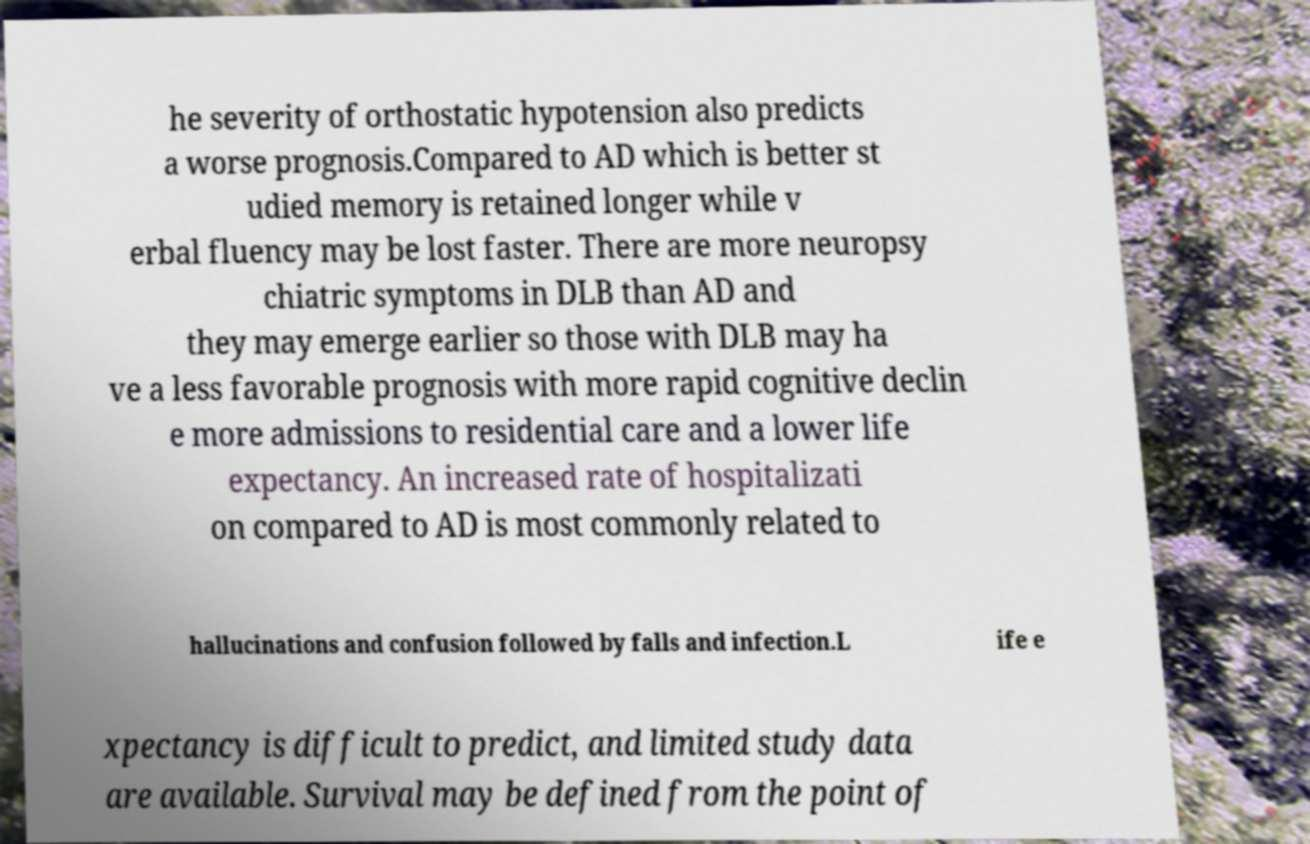What messages or text are displayed in this image? I need them in a readable, typed format. he severity of orthostatic hypotension also predicts a worse prognosis.Compared to AD which is better st udied memory is retained longer while v erbal fluency may be lost faster. There are more neuropsy chiatric symptoms in DLB than AD and they may emerge earlier so those with DLB may ha ve a less favorable prognosis with more rapid cognitive declin e more admissions to residential care and a lower life expectancy. An increased rate of hospitalizati on compared to AD is most commonly related to hallucinations and confusion followed by falls and infection.L ife e xpectancy is difficult to predict, and limited study data are available. Survival may be defined from the point of 